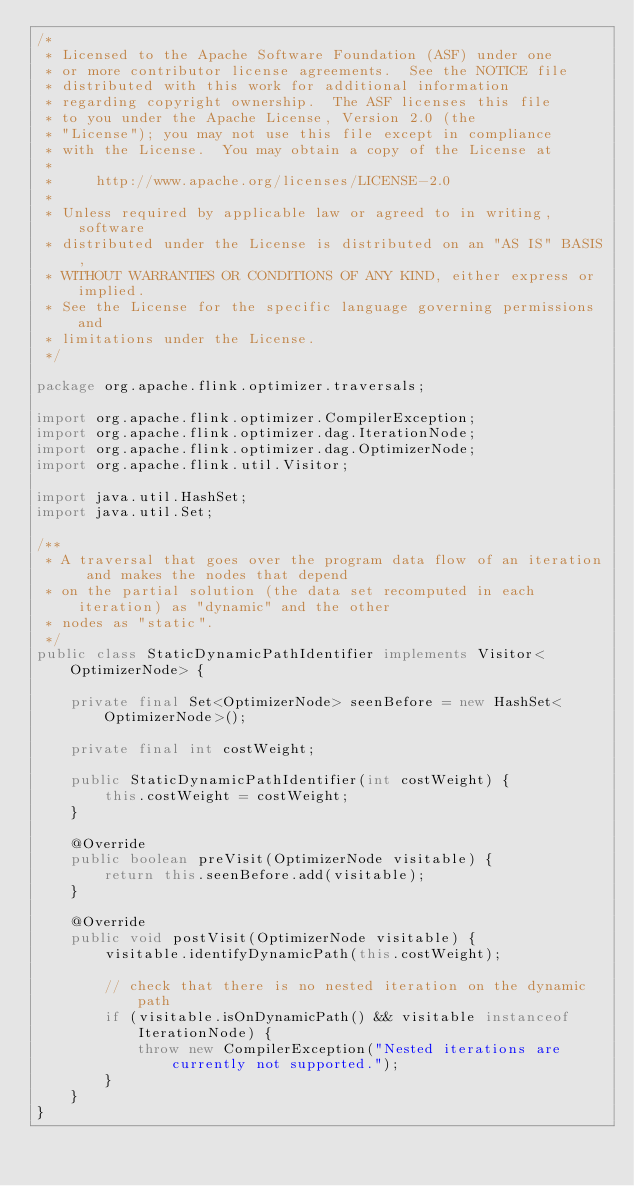<code> <loc_0><loc_0><loc_500><loc_500><_Java_>/*
 * Licensed to the Apache Software Foundation (ASF) under one
 * or more contributor license agreements.  See the NOTICE file
 * distributed with this work for additional information
 * regarding copyright ownership.  The ASF licenses this file
 * to you under the Apache License, Version 2.0 (the
 * "License"); you may not use this file except in compliance
 * with the License.  You may obtain a copy of the License at
 *
 *     http://www.apache.org/licenses/LICENSE-2.0
 *
 * Unless required by applicable law or agreed to in writing, software
 * distributed under the License is distributed on an "AS IS" BASIS,
 * WITHOUT WARRANTIES OR CONDITIONS OF ANY KIND, either express or implied.
 * See the License for the specific language governing permissions and
 * limitations under the License.
 */

package org.apache.flink.optimizer.traversals;

import org.apache.flink.optimizer.CompilerException;
import org.apache.flink.optimizer.dag.IterationNode;
import org.apache.flink.optimizer.dag.OptimizerNode;
import org.apache.flink.util.Visitor;

import java.util.HashSet;
import java.util.Set;

/**
 * A traversal that goes over the program data flow of an iteration and makes the nodes that depend
 * on the partial solution (the data set recomputed in each iteration) as "dynamic" and the other
 * nodes as "static".
 */
public class StaticDynamicPathIdentifier implements Visitor<OptimizerNode> {

    private final Set<OptimizerNode> seenBefore = new HashSet<OptimizerNode>();

    private final int costWeight;

    public StaticDynamicPathIdentifier(int costWeight) {
        this.costWeight = costWeight;
    }

    @Override
    public boolean preVisit(OptimizerNode visitable) {
        return this.seenBefore.add(visitable);
    }

    @Override
    public void postVisit(OptimizerNode visitable) {
        visitable.identifyDynamicPath(this.costWeight);

        // check that there is no nested iteration on the dynamic path
        if (visitable.isOnDynamicPath() && visitable instanceof IterationNode) {
            throw new CompilerException("Nested iterations are currently not supported.");
        }
    }
}
</code> 